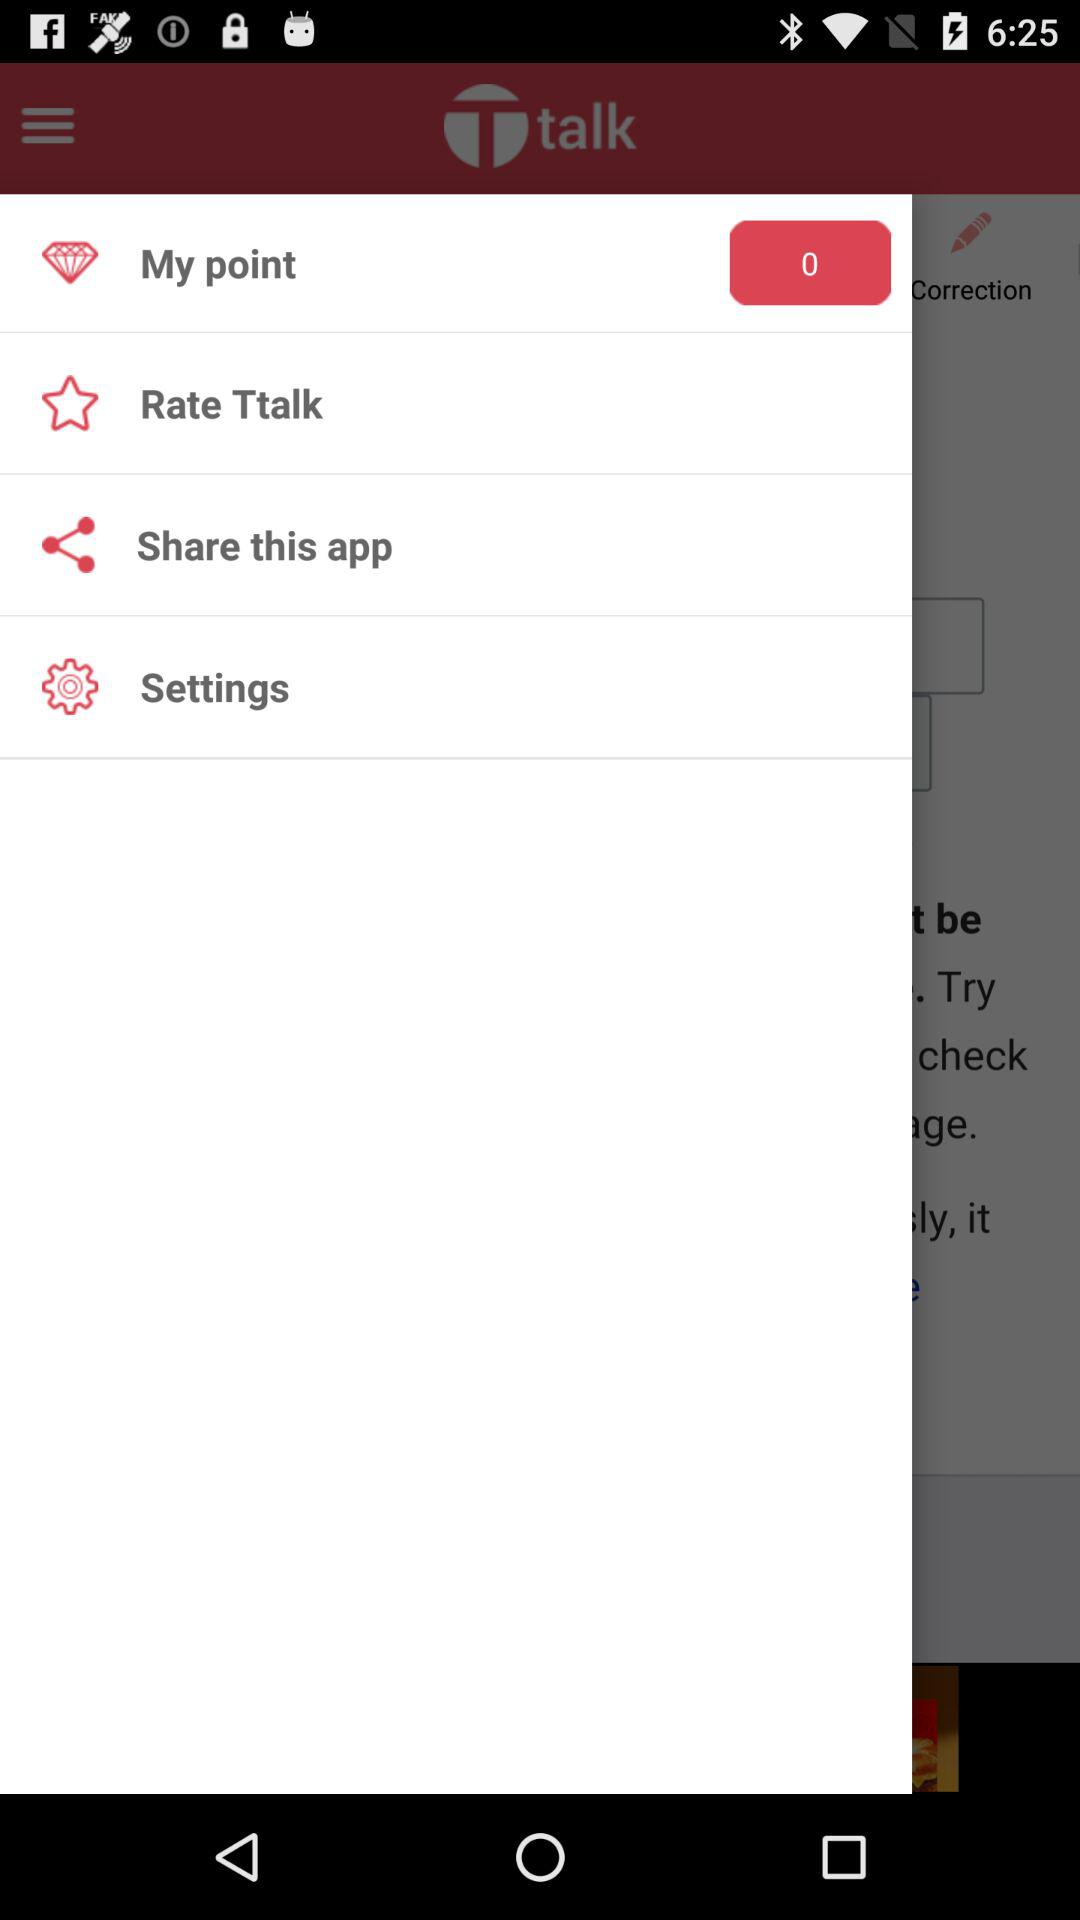What is the number for "My point"? The given number is 0 for "My point". 